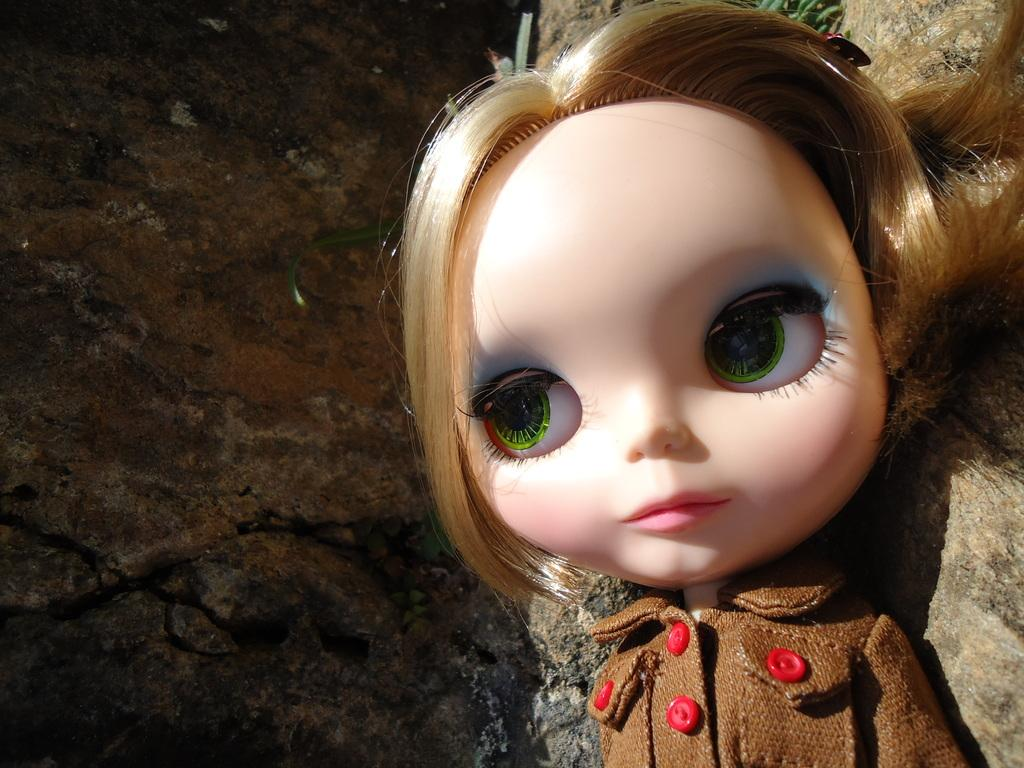What is the main subject in the image? There is a doll in the image. Are there any other objects or elements in the image besides the doll? Yes, there is a rock in the image. What type of tank is being used by the team in the image? There is no tank or team present in the image; it only features a doll and a rock. 